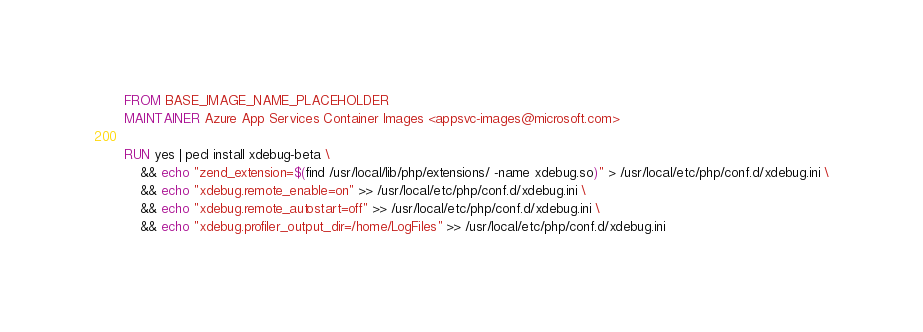<code> <loc_0><loc_0><loc_500><loc_500><_Dockerfile_>FROM BASE_IMAGE_NAME_PLACEHOLDER
MAINTAINER Azure App Services Container Images <appsvc-images@microsoft.com>

RUN yes | pecl install xdebug-beta \
    && echo "zend_extension=$(find /usr/local/lib/php/extensions/ -name xdebug.so)" > /usr/local/etc/php/conf.d/xdebug.ini \
    && echo "xdebug.remote_enable=on" >> /usr/local/etc/php/conf.d/xdebug.ini \
    && echo "xdebug.remote_autostart=off" >> /usr/local/etc/php/conf.d/xdebug.ini \
    && echo "xdebug.profiler_output_dir=/home/LogFiles" >> /usr/local/etc/php/conf.d/xdebug.ini</code> 